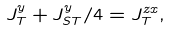Convert formula to latex. <formula><loc_0><loc_0><loc_500><loc_500>J _ { T } ^ { y } + J _ { S T } ^ { y } / 4 = J _ { T } ^ { z x } ,</formula> 